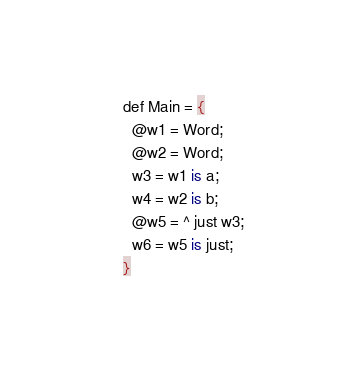<code> <loc_0><loc_0><loc_500><loc_500><_SQL_>def Main = {
  @w1 = Word;
  @w2 = Word;
  w3 = w1 is a;
  w4 = w2 is b;
  @w5 = ^ just w3;
  w6 = w5 is just;
}
</code> 